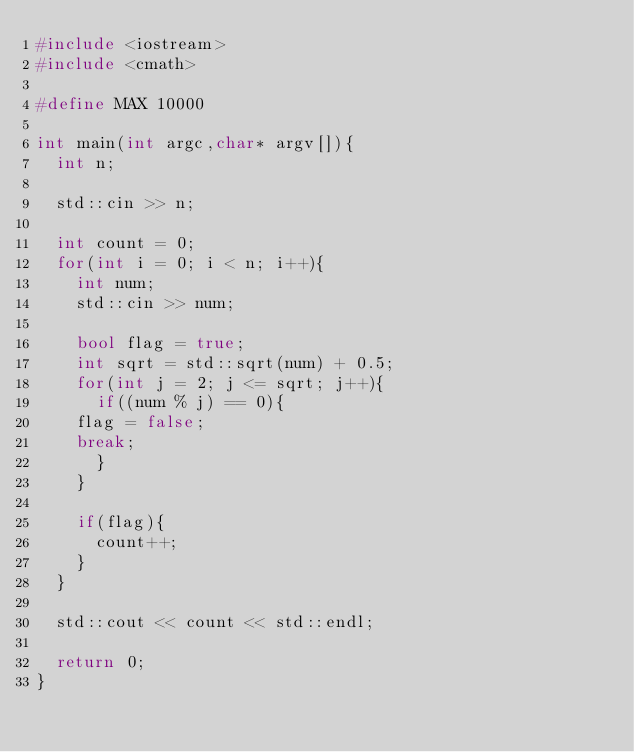Convert code to text. <code><loc_0><loc_0><loc_500><loc_500><_C++_>#include <iostream>
#include <cmath>

#define MAX 10000

int main(int argc,char* argv[]){
  int n;

  std::cin >> n;
  
  int count = 0;
  for(int i = 0; i < n; i++){
    int num;
    std::cin >> num;

    bool flag = true;
    int sqrt = std::sqrt(num) + 0.5;
    for(int j = 2; j <= sqrt; j++){
      if((num % j) == 0){
	flag = false;
	break;
      }
    }

    if(flag){
      count++;
    }
  }

  std::cout << count << std::endl;

  return 0;  
}</code> 